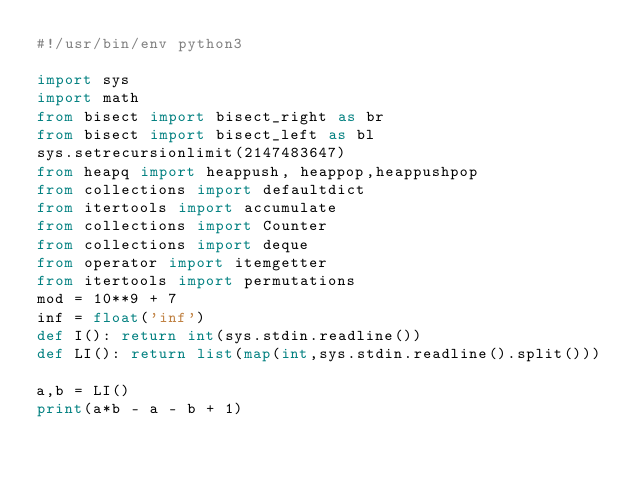Convert code to text. <code><loc_0><loc_0><loc_500><loc_500><_Python_>#!/usr/bin/env python3

import sys
import math
from bisect import bisect_right as br
from bisect import bisect_left as bl
sys.setrecursionlimit(2147483647)
from heapq import heappush, heappop,heappushpop
from collections import defaultdict
from itertools import accumulate
from collections import Counter
from collections import deque
from operator import itemgetter
from itertools import permutations
mod = 10**9 + 7
inf = float('inf')
def I(): return int(sys.stdin.readline())
def LI(): return list(map(int,sys.stdin.readline().split()))

a,b = LI()
print(a*b - a - b + 1)
</code> 